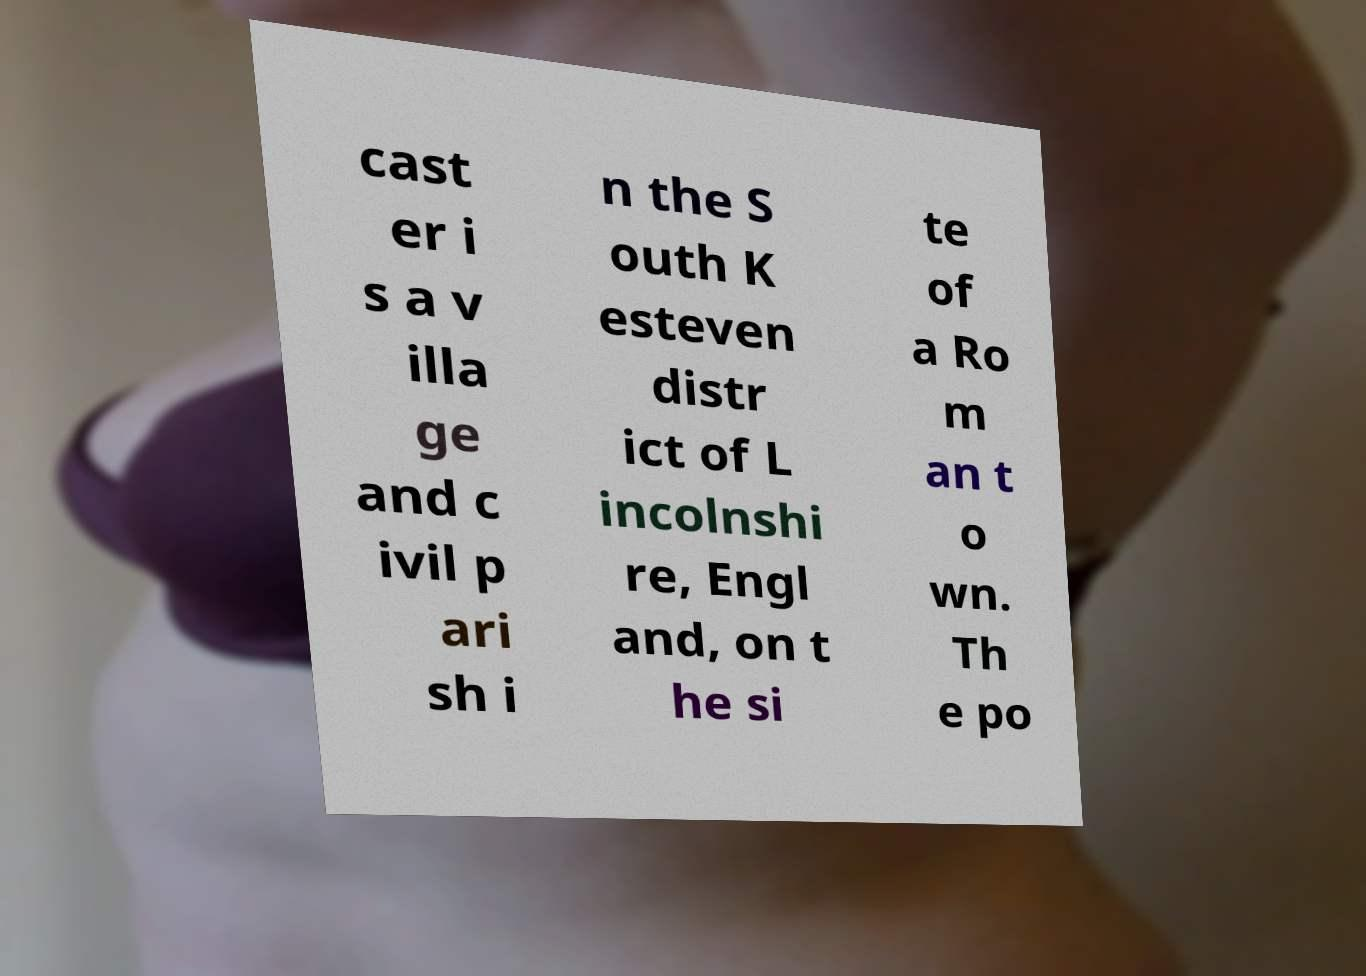Please read and relay the text visible in this image. What does it say? cast er i s a v illa ge and c ivil p ari sh i n the S outh K esteven distr ict of L incolnshi re, Engl and, on t he si te of a Ro m an t o wn. Th e po 